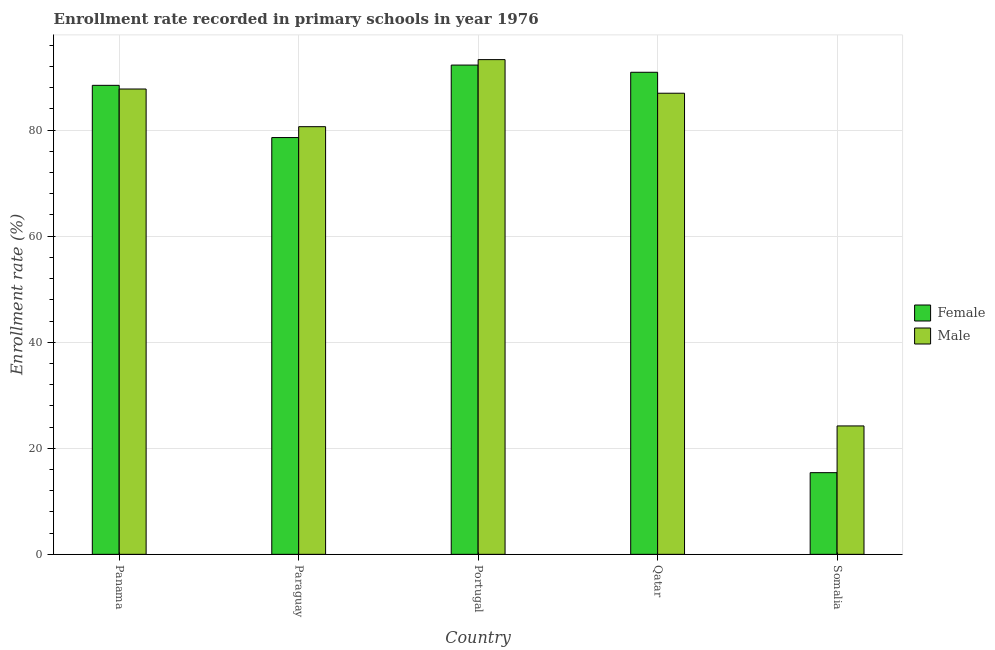How many different coloured bars are there?
Provide a succinct answer. 2. How many groups of bars are there?
Give a very brief answer. 5. How many bars are there on the 3rd tick from the right?
Keep it short and to the point. 2. What is the label of the 1st group of bars from the left?
Provide a succinct answer. Panama. In how many cases, is the number of bars for a given country not equal to the number of legend labels?
Keep it short and to the point. 0. What is the enrollment rate of male students in Somalia?
Provide a short and direct response. 24.21. Across all countries, what is the maximum enrollment rate of male students?
Your answer should be very brief. 93.3. Across all countries, what is the minimum enrollment rate of female students?
Offer a terse response. 15.4. In which country was the enrollment rate of male students minimum?
Offer a terse response. Somalia. What is the total enrollment rate of female students in the graph?
Provide a short and direct response. 365.63. What is the difference between the enrollment rate of male students in Qatar and that in Somalia?
Your answer should be very brief. 62.74. What is the difference between the enrollment rate of female students in Qatar and the enrollment rate of male students in Panama?
Give a very brief answer. 3.16. What is the average enrollment rate of male students per country?
Your answer should be very brief. 74.58. What is the difference between the enrollment rate of male students and enrollment rate of female students in Portugal?
Make the answer very short. 1.03. What is the ratio of the enrollment rate of female students in Panama to that in Qatar?
Ensure brevity in your answer.  0.97. Is the enrollment rate of male students in Portugal less than that in Somalia?
Offer a terse response. No. What is the difference between the highest and the second highest enrollment rate of female students?
Provide a succinct answer. 1.36. What is the difference between the highest and the lowest enrollment rate of male students?
Your answer should be very brief. 69.08. Is the sum of the enrollment rate of male students in Portugal and Somalia greater than the maximum enrollment rate of female students across all countries?
Your response must be concise. Yes. What does the 2nd bar from the right in Panama represents?
Your response must be concise. Female. Are all the bars in the graph horizontal?
Your response must be concise. No. How many countries are there in the graph?
Keep it short and to the point. 5. Are the values on the major ticks of Y-axis written in scientific E-notation?
Provide a succinct answer. No. Where does the legend appear in the graph?
Make the answer very short. Center right. What is the title of the graph?
Offer a terse response. Enrollment rate recorded in primary schools in year 1976. Does "Stunting" appear as one of the legend labels in the graph?
Keep it short and to the point. No. What is the label or title of the X-axis?
Keep it short and to the point. Country. What is the label or title of the Y-axis?
Offer a very short reply. Enrollment rate (%). What is the Enrollment rate (%) of Female in Panama?
Keep it short and to the point. 88.45. What is the Enrollment rate (%) of Male in Panama?
Your answer should be compact. 87.76. What is the Enrollment rate (%) of Female in Paraguay?
Your answer should be compact. 78.6. What is the Enrollment rate (%) in Male in Paraguay?
Keep it short and to the point. 80.65. What is the Enrollment rate (%) in Female in Portugal?
Your answer should be very brief. 92.27. What is the Enrollment rate (%) in Male in Portugal?
Your response must be concise. 93.3. What is the Enrollment rate (%) in Female in Qatar?
Keep it short and to the point. 90.91. What is the Enrollment rate (%) of Male in Qatar?
Your response must be concise. 86.96. What is the Enrollment rate (%) of Female in Somalia?
Keep it short and to the point. 15.4. What is the Enrollment rate (%) in Male in Somalia?
Offer a terse response. 24.21. Across all countries, what is the maximum Enrollment rate (%) in Female?
Ensure brevity in your answer.  92.27. Across all countries, what is the maximum Enrollment rate (%) of Male?
Provide a succinct answer. 93.3. Across all countries, what is the minimum Enrollment rate (%) in Female?
Offer a terse response. 15.4. Across all countries, what is the minimum Enrollment rate (%) in Male?
Provide a succinct answer. 24.21. What is the total Enrollment rate (%) of Female in the graph?
Make the answer very short. 365.63. What is the total Enrollment rate (%) of Male in the graph?
Your answer should be very brief. 372.88. What is the difference between the Enrollment rate (%) of Female in Panama and that in Paraguay?
Provide a succinct answer. 9.85. What is the difference between the Enrollment rate (%) in Male in Panama and that in Paraguay?
Give a very brief answer. 7.11. What is the difference between the Enrollment rate (%) in Female in Panama and that in Portugal?
Give a very brief answer. -3.82. What is the difference between the Enrollment rate (%) in Male in Panama and that in Portugal?
Give a very brief answer. -5.54. What is the difference between the Enrollment rate (%) of Female in Panama and that in Qatar?
Offer a very short reply. -2.47. What is the difference between the Enrollment rate (%) in Male in Panama and that in Qatar?
Ensure brevity in your answer.  0.8. What is the difference between the Enrollment rate (%) in Female in Panama and that in Somalia?
Your answer should be compact. 73.04. What is the difference between the Enrollment rate (%) in Male in Panama and that in Somalia?
Your answer should be very brief. 63.54. What is the difference between the Enrollment rate (%) of Female in Paraguay and that in Portugal?
Give a very brief answer. -13.67. What is the difference between the Enrollment rate (%) in Male in Paraguay and that in Portugal?
Your answer should be compact. -12.65. What is the difference between the Enrollment rate (%) of Female in Paraguay and that in Qatar?
Offer a very short reply. -12.31. What is the difference between the Enrollment rate (%) of Male in Paraguay and that in Qatar?
Your response must be concise. -6.31. What is the difference between the Enrollment rate (%) of Female in Paraguay and that in Somalia?
Your response must be concise. 63.2. What is the difference between the Enrollment rate (%) of Male in Paraguay and that in Somalia?
Give a very brief answer. 56.44. What is the difference between the Enrollment rate (%) in Female in Portugal and that in Qatar?
Your response must be concise. 1.36. What is the difference between the Enrollment rate (%) of Male in Portugal and that in Qatar?
Offer a terse response. 6.34. What is the difference between the Enrollment rate (%) of Female in Portugal and that in Somalia?
Provide a succinct answer. 76.87. What is the difference between the Enrollment rate (%) of Male in Portugal and that in Somalia?
Keep it short and to the point. 69.08. What is the difference between the Enrollment rate (%) of Female in Qatar and that in Somalia?
Provide a succinct answer. 75.51. What is the difference between the Enrollment rate (%) of Male in Qatar and that in Somalia?
Give a very brief answer. 62.74. What is the difference between the Enrollment rate (%) in Female in Panama and the Enrollment rate (%) in Male in Paraguay?
Ensure brevity in your answer.  7.8. What is the difference between the Enrollment rate (%) in Female in Panama and the Enrollment rate (%) in Male in Portugal?
Your answer should be very brief. -4.85. What is the difference between the Enrollment rate (%) of Female in Panama and the Enrollment rate (%) of Male in Qatar?
Your answer should be very brief. 1.49. What is the difference between the Enrollment rate (%) in Female in Panama and the Enrollment rate (%) in Male in Somalia?
Offer a terse response. 64.23. What is the difference between the Enrollment rate (%) of Female in Paraguay and the Enrollment rate (%) of Male in Portugal?
Make the answer very short. -14.7. What is the difference between the Enrollment rate (%) in Female in Paraguay and the Enrollment rate (%) in Male in Qatar?
Provide a short and direct response. -8.36. What is the difference between the Enrollment rate (%) in Female in Paraguay and the Enrollment rate (%) in Male in Somalia?
Offer a very short reply. 54.39. What is the difference between the Enrollment rate (%) in Female in Portugal and the Enrollment rate (%) in Male in Qatar?
Your response must be concise. 5.31. What is the difference between the Enrollment rate (%) of Female in Portugal and the Enrollment rate (%) of Male in Somalia?
Provide a succinct answer. 68.05. What is the difference between the Enrollment rate (%) of Female in Qatar and the Enrollment rate (%) of Male in Somalia?
Offer a terse response. 66.7. What is the average Enrollment rate (%) in Female per country?
Make the answer very short. 73.13. What is the average Enrollment rate (%) of Male per country?
Offer a terse response. 74.58. What is the difference between the Enrollment rate (%) in Female and Enrollment rate (%) in Male in Panama?
Your answer should be compact. 0.69. What is the difference between the Enrollment rate (%) of Female and Enrollment rate (%) of Male in Paraguay?
Your response must be concise. -2.05. What is the difference between the Enrollment rate (%) in Female and Enrollment rate (%) in Male in Portugal?
Offer a very short reply. -1.03. What is the difference between the Enrollment rate (%) in Female and Enrollment rate (%) in Male in Qatar?
Provide a succinct answer. 3.95. What is the difference between the Enrollment rate (%) of Female and Enrollment rate (%) of Male in Somalia?
Your answer should be compact. -8.81. What is the ratio of the Enrollment rate (%) of Female in Panama to that in Paraguay?
Offer a very short reply. 1.13. What is the ratio of the Enrollment rate (%) in Male in Panama to that in Paraguay?
Your answer should be very brief. 1.09. What is the ratio of the Enrollment rate (%) of Female in Panama to that in Portugal?
Offer a terse response. 0.96. What is the ratio of the Enrollment rate (%) in Male in Panama to that in Portugal?
Keep it short and to the point. 0.94. What is the ratio of the Enrollment rate (%) of Female in Panama to that in Qatar?
Provide a succinct answer. 0.97. What is the ratio of the Enrollment rate (%) of Male in Panama to that in Qatar?
Offer a terse response. 1.01. What is the ratio of the Enrollment rate (%) of Female in Panama to that in Somalia?
Provide a succinct answer. 5.74. What is the ratio of the Enrollment rate (%) of Male in Panama to that in Somalia?
Ensure brevity in your answer.  3.62. What is the ratio of the Enrollment rate (%) of Female in Paraguay to that in Portugal?
Make the answer very short. 0.85. What is the ratio of the Enrollment rate (%) of Male in Paraguay to that in Portugal?
Your answer should be compact. 0.86. What is the ratio of the Enrollment rate (%) in Female in Paraguay to that in Qatar?
Your response must be concise. 0.86. What is the ratio of the Enrollment rate (%) of Male in Paraguay to that in Qatar?
Your response must be concise. 0.93. What is the ratio of the Enrollment rate (%) of Female in Paraguay to that in Somalia?
Offer a very short reply. 5.1. What is the ratio of the Enrollment rate (%) of Male in Paraguay to that in Somalia?
Make the answer very short. 3.33. What is the ratio of the Enrollment rate (%) in Female in Portugal to that in Qatar?
Give a very brief answer. 1.01. What is the ratio of the Enrollment rate (%) in Male in Portugal to that in Qatar?
Offer a terse response. 1.07. What is the ratio of the Enrollment rate (%) of Female in Portugal to that in Somalia?
Ensure brevity in your answer.  5.99. What is the ratio of the Enrollment rate (%) in Male in Portugal to that in Somalia?
Make the answer very short. 3.85. What is the ratio of the Enrollment rate (%) in Female in Qatar to that in Somalia?
Offer a very short reply. 5.9. What is the ratio of the Enrollment rate (%) of Male in Qatar to that in Somalia?
Ensure brevity in your answer.  3.59. What is the difference between the highest and the second highest Enrollment rate (%) of Female?
Make the answer very short. 1.36. What is the difference between the highest and the second highest Enrollment rate (%) of Male?
Provide a short and direct response. 5.54. What is the difference between the highest and the lowest Enrollment rate (%) of Female?
Keep it short and to the point. 76.87. What is the difference between the highest and the lowest Enrollment rate (%) of Male?
Give a very brief answer. 69.08. 